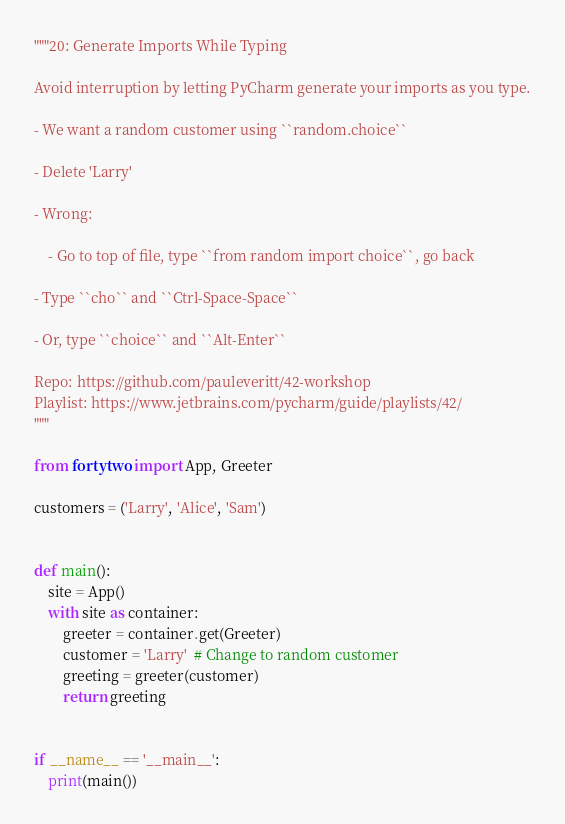Convert code to text. <code><loc_0><loc_0><loc_500><loc_500><_Python_>"""20: Generate Imports While Typing

Avoid interruption by letting PyCharm generate your imports as you type.

- We want a random customer using ``random.choice``

- Delete 'Larry'

- Wrong:

    - Go to top of file, type ``from random import choice``, go back

- Type ``cho`` and ``Ctrl-Space-Space``

- Or, type ``choice`` and ``Alt-Enter``

Repo: https://github.com/pauleveritt/42-workshop
Playlist: https://www.jetbrains.com/pycharm/guide/playlists/42/
"""

from fortytwo import App, Greeter

customers = ('Larry', 'Alice', 'Sam')


def main():
    site = App()
    with site as container:
        greeter = container.get(Greeter)
        customer = 'Larry'  # Change to random customer
        greeting = greeter(customer)
        return greeting


if __name__ == '__main__':
    print(main())
</code> 